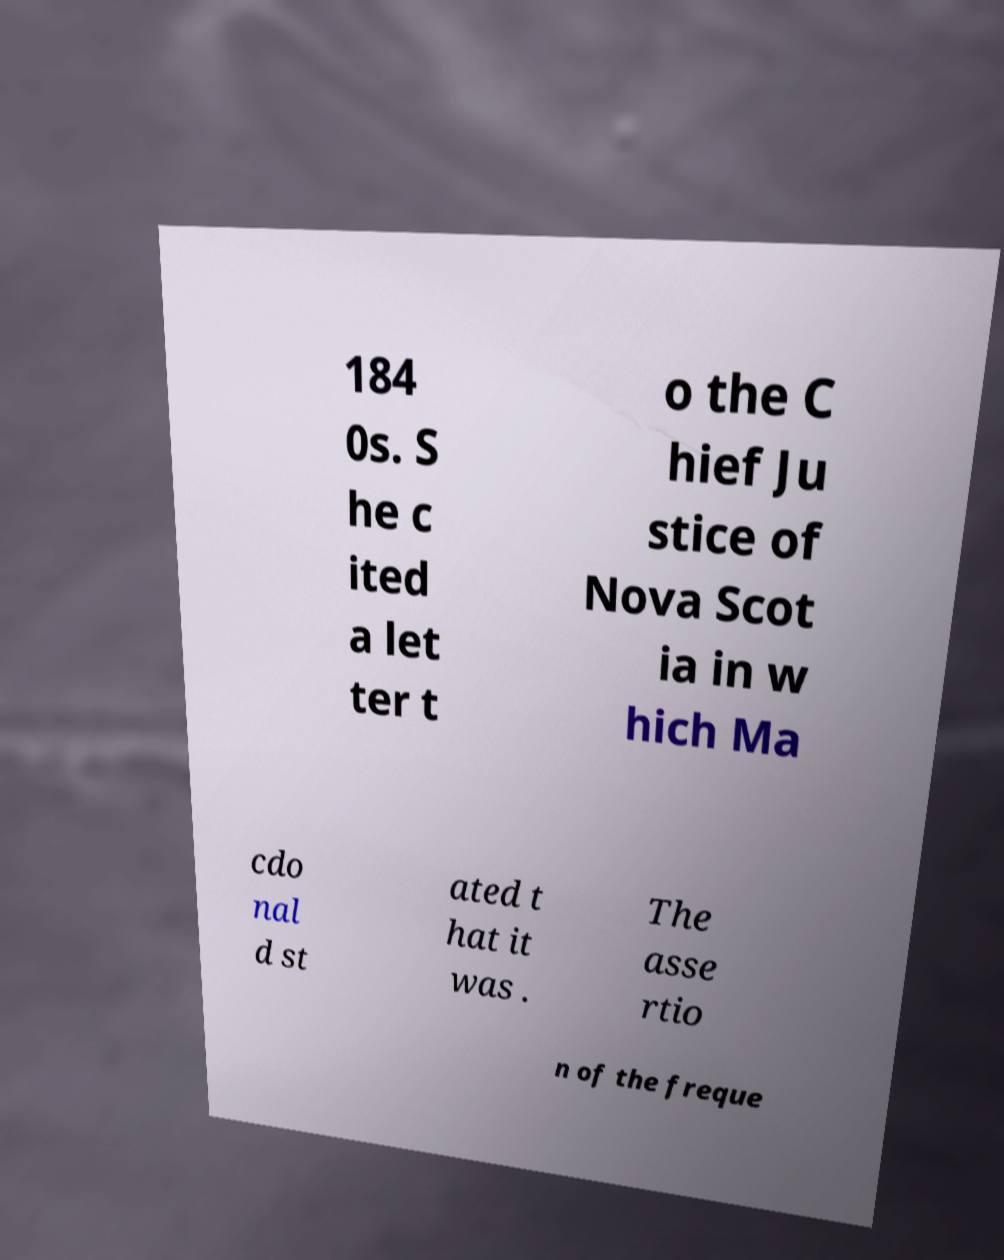There's text embedded in this image that I need extracted. Can you transcribe it verbatim? 184 0s. S he c ited a let ter t o the C hief Ju stice of Nova Scot ia in w hich Ma cdo nal d st ated t hat it was . The asse rtio n of the freque 